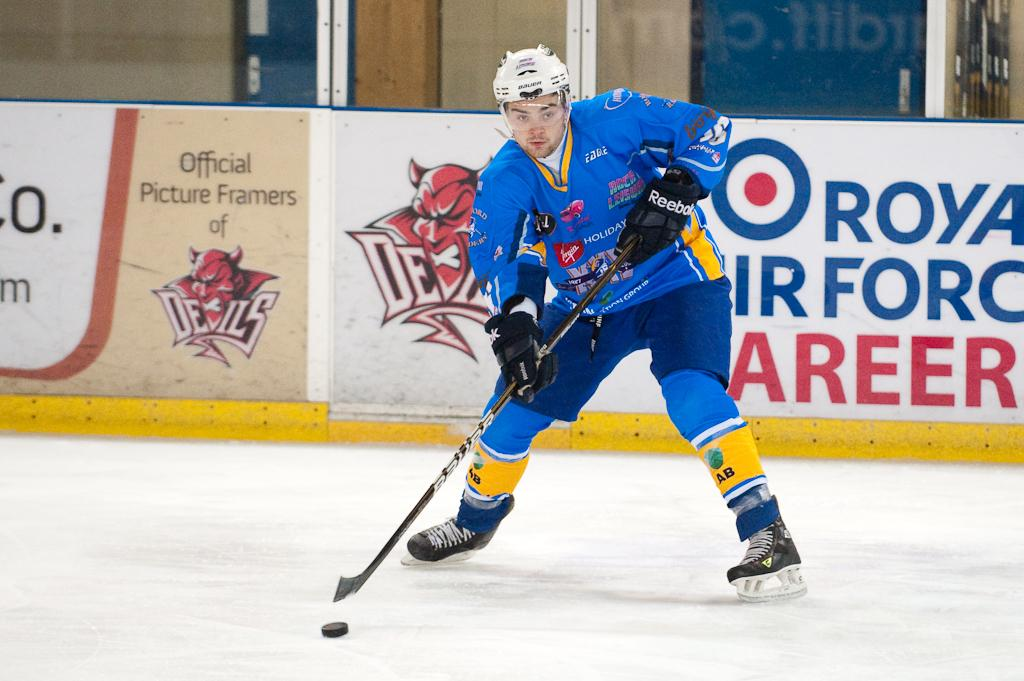<image>
Relay a brief, clear account of the picture shown. the name Royal is on the side of a rink 